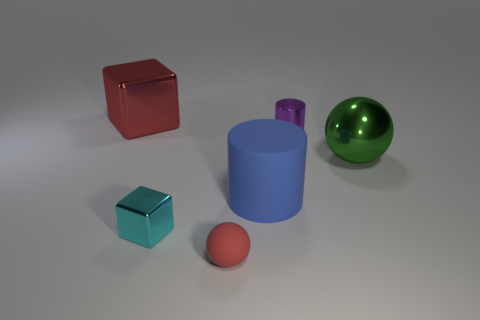What is the size of the matte object that is the same color as the large metal cube? The small cyan matte cube is similar in color to the larger shiny metal cube. Despite sharing a hue, their sizes differ considerably, with the matte cube being much smaller in comparison. 